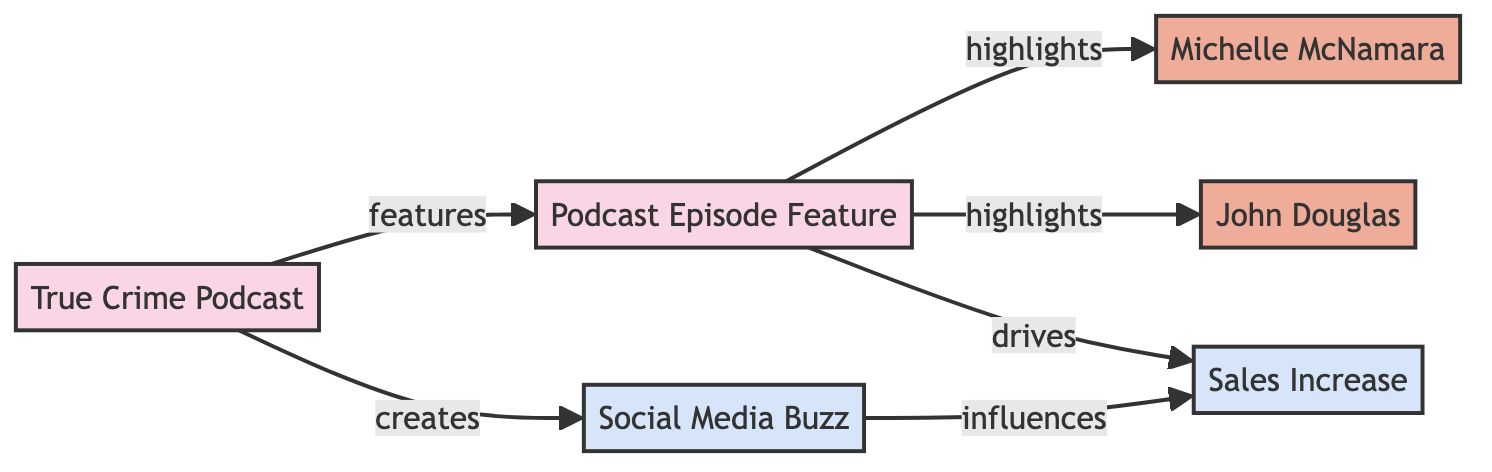What is the total number of nodes in the diagram? The diagram contains six distinct nodes: True Crime Podcast, Michelle McNamara, John Douglas, Sales Increase, Podcast Episode Feature, and Social Media Buzz. Therefore, counting each node leads to a total of six.
Answer: 6 Who are the authors highlighted in the podcast episodes? The diagram indicates that there are two authors connected to the Podcast Episode node: Michelle McNamara and John Douglas.
Answer: Michelle McNamara and John Douglas Which node does the True Crime Podcast create an influence on? The True Crime Podcast points towards the Social Media Buzz node in the graph, indicating that it generates buzz on social media.
Answer: Social Media Buzz What does the Podcast Episode drive? According to the edges in the diagram, the Podcast Episode directs to the Sales Increase node, meaning it contributes to increasing sales.
Answer: Sales Increase How many edges are connected to the Sales Increase node? By examining the edges starting from the Sales Increase node, we find that it has two incoming edges: one from Podcast Episode and one from Social Media Buzz. Hence, the total number of edges connected to the Sales Increase node is two.
Answer: 2 What relationship exists between Social Media Buzz and Sales Increase? The diagram shows that Social Media Buzz influences Sales Increase, indicating a causal relationship where social media engagement impacts book sales.
Answer: influences Which node features podcast episodes? The True Crime Podcast node features the Podcast Episode, as represented by the directed edge from True Crime Podcast to Podcast Episode.
Answer: Podcast Episode What drives the Sales Increase according to the diagram? The edge departing from the Podcast Episode node indicates that it drives the Sales Increase, demonstrating that mentions in podcasts boost sales figures.
Answer: Podcast Episode 